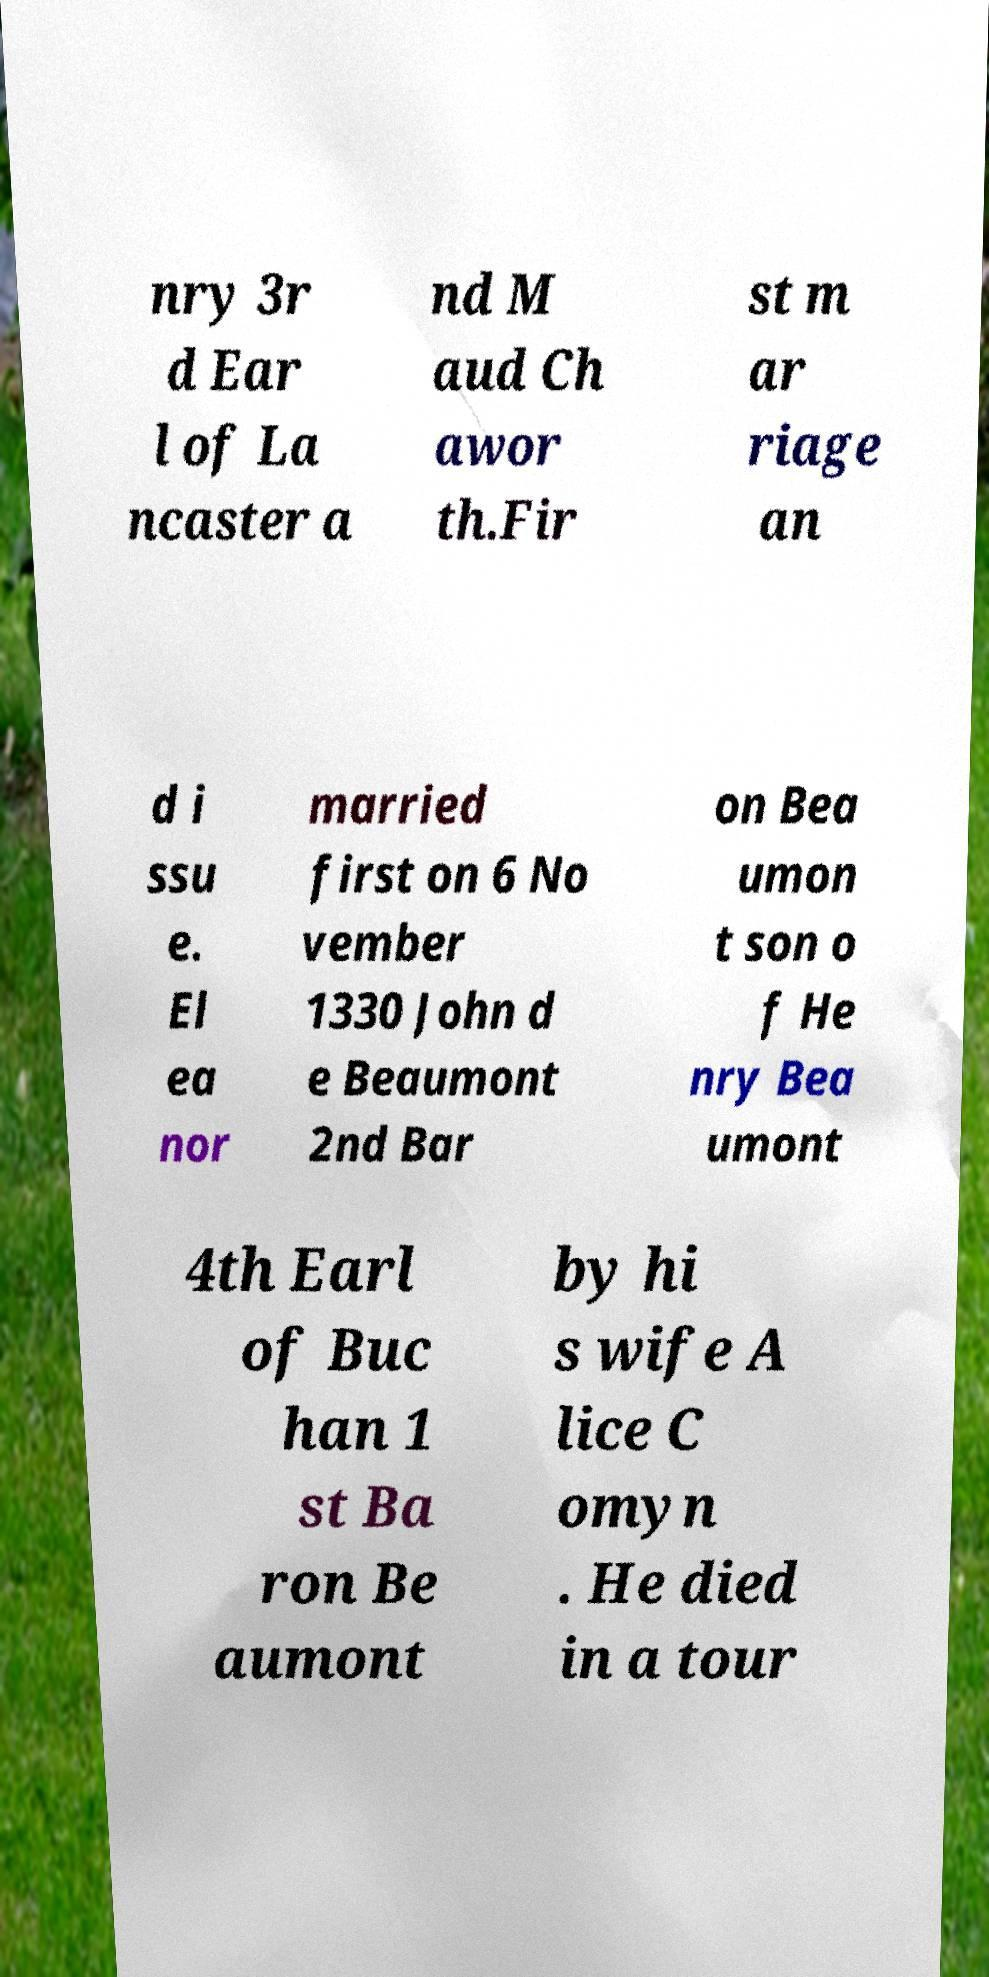For documentation purposes, I need the text within this image transcribed. Could you provide that? nry 3r d Ear l of La ncaster a nd M aud Ch awor th.Fir st m ar riage an d i ssu e. El ea nor married first on 6 No vember 1330 John d e Beaumont 2nd Bar on Bea umon t son o f He nry Bea umont 4th Earl of Buc han 1 st Ba ron Be aumont by hi s wife A lice C omyn . He died in a tour 